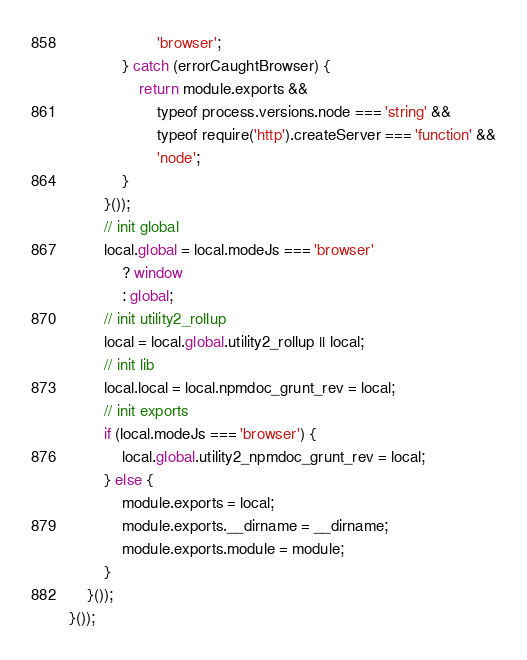<code> <loc_0><loc_0><loc_500><loc_500><_JavaScript_>                    'browser';
            } catch (errorCaughtBrowser) {
                return module.exports &&
                    typeof process.versions.node === 'string' &&
                    typeof require('http').createServer === 'function' &&
                    'node';
            }
        }());
        // init global
        local.global = local.modeJs === 'browser'
            ? window
            : global;
        // init utility2_rollup
        local = local.global.utility2_rollup || local;
        // init lib
        local.local = local.npmdoc_grunt_rev = local;
        // init exports
        if (local.modeJs === 'browser') {
            local.global.utility2_npmdoc_grunt_rev = local;
        } else {
            module.exports = local;
            module.exports.__dirname = __dirname;
            module.exports.module = module;
        }
    }());
}());
</code> 